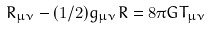Convert formula to latex. <formula><loc_0><loc_0><loc_500><loc_500>R _ { \mu \nu } - ( 1 / 2 ) g _ { \mu \nu } R = 8 \pi G T _ { \mu \nu }</formula> 